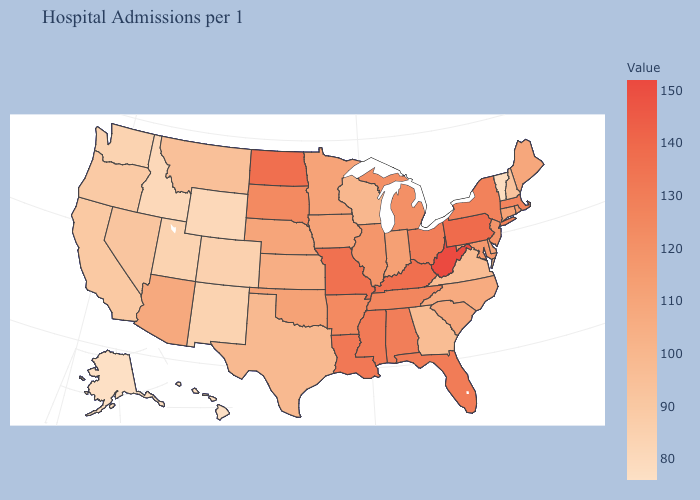Does Tennessee have the lowest value in the South?
Keep it brief. No. Does West Virginia have a higher value than Virginia?
Be succinct. Yes. Does Hawaii have the lowest value in the USA?
Write a very short answer. Yes. Which states hav the highest value in the South?
Be succinct. West Virginia. Does Vermont have the lowest value in the Northeast?
Short answer required. Yes. Does Louisiana have the highest value in the USA?
Short answer required. No. 